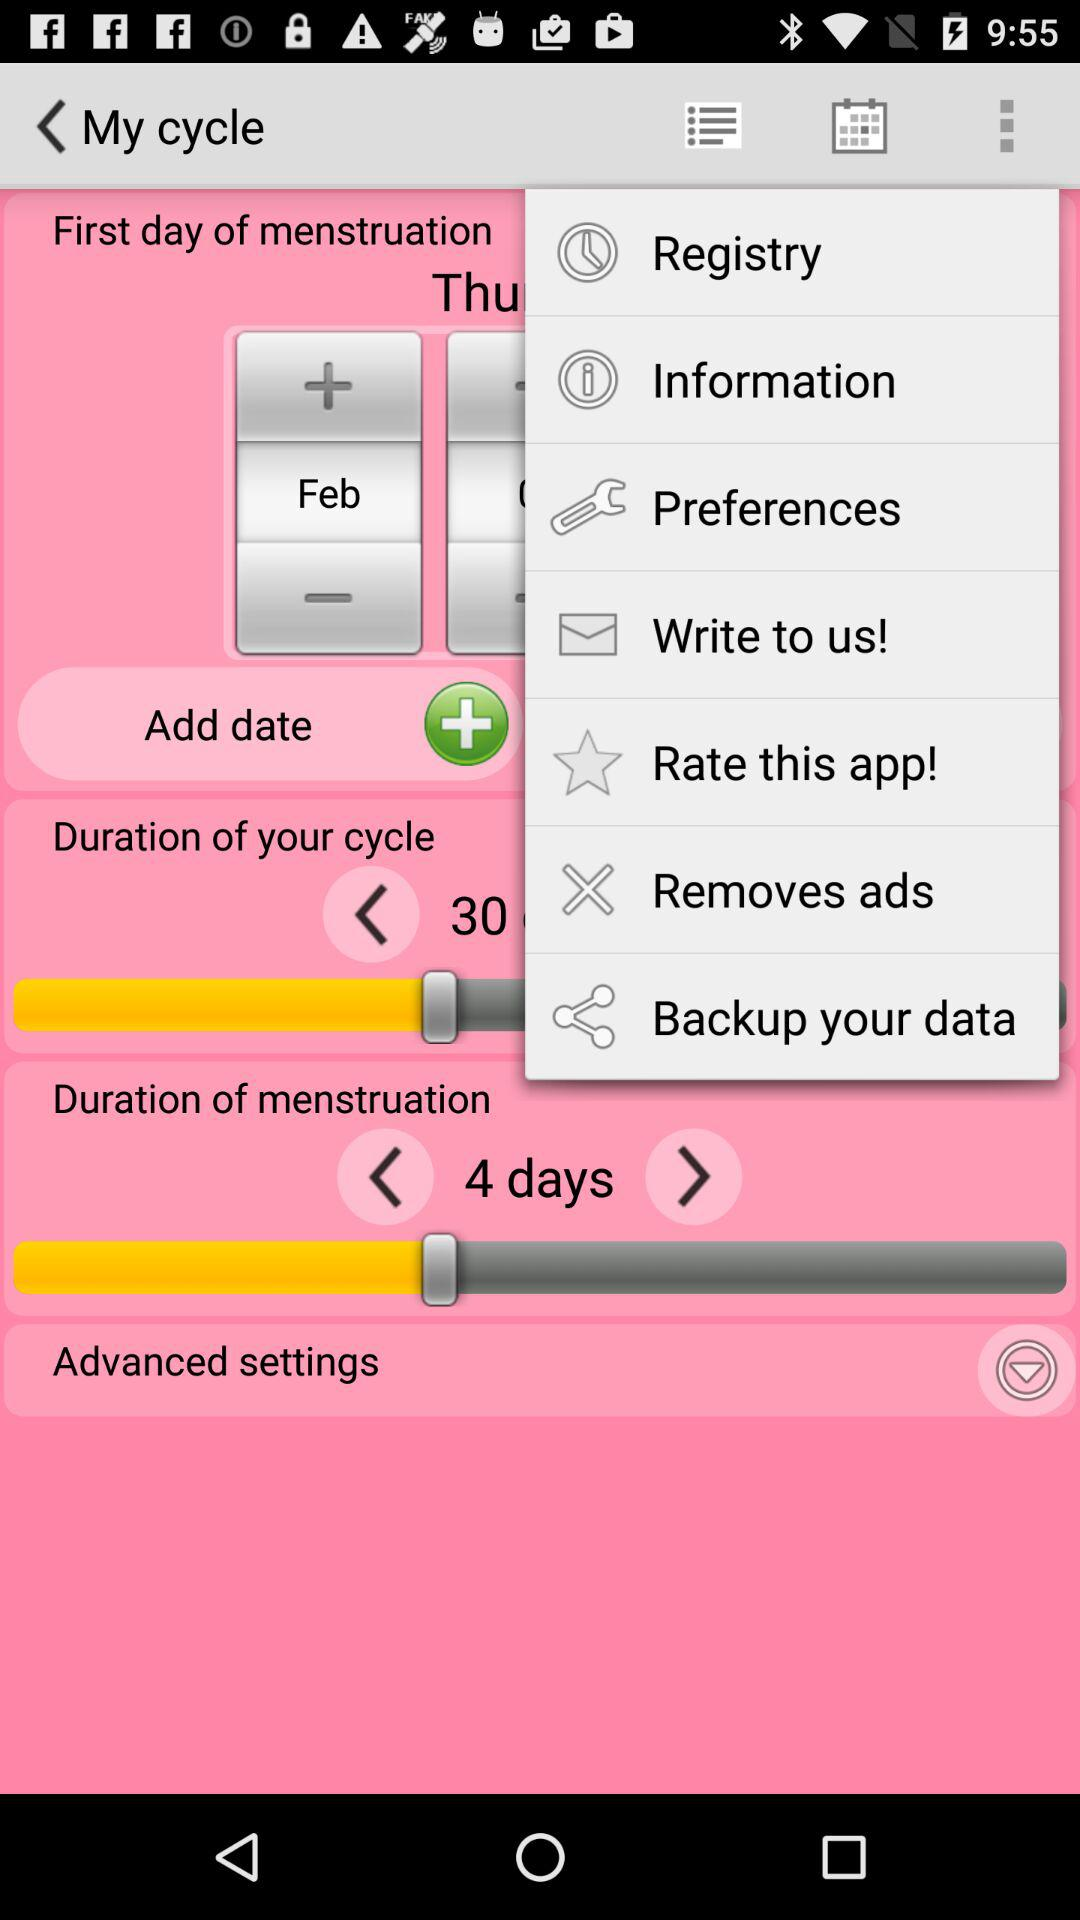What is the month of menstruation? The month of menstruation is February. 